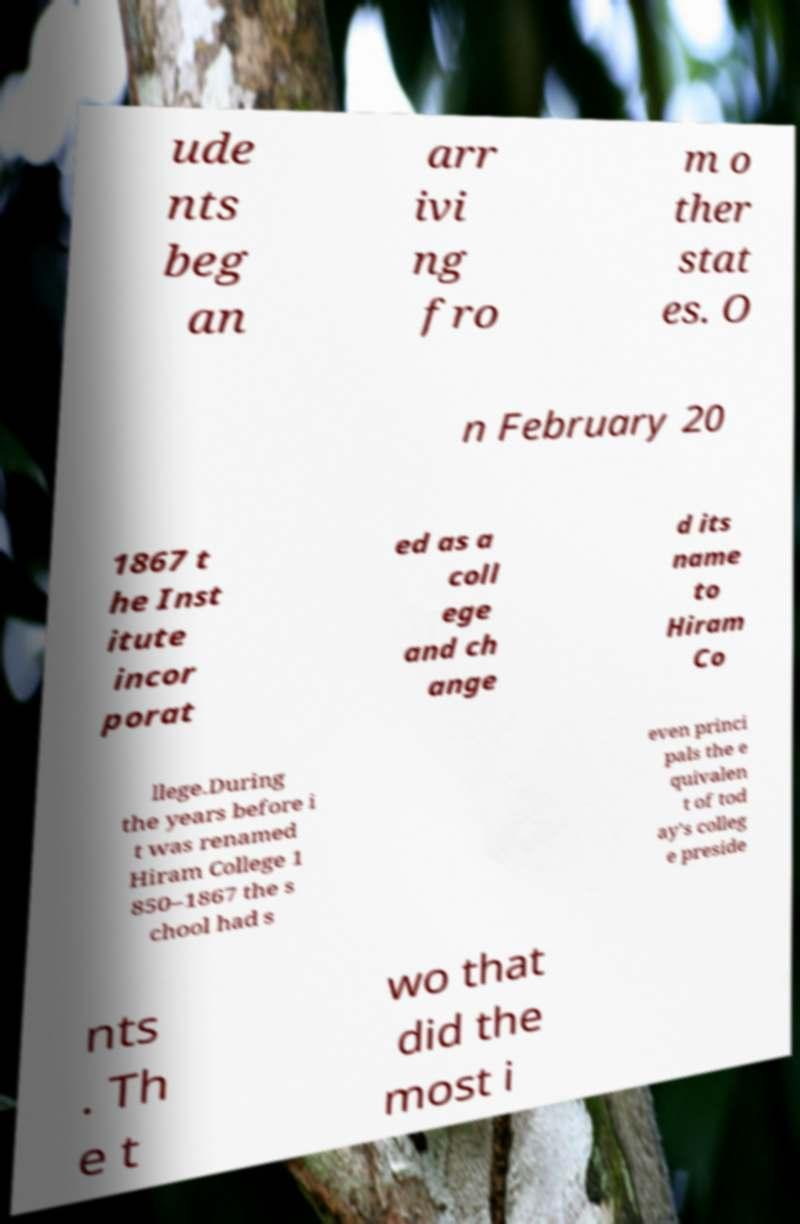Can you read and provide the text displayed in the image?This photo seems to have some interesting text. Can you extract and type it out for me? ude nts beg an arr ivi ng fro m o ther stat es. O n February 20 1867 t he Inst itute incor porat ed as a coll ege and ch ange d its name to Hiram Co llege.During the years before i t was renamed Hiram College 1 850–1867 the s chool had s even princi pals the e quivalen t of tod ay's colleg e preside nts . Th e t wo that did the most i 